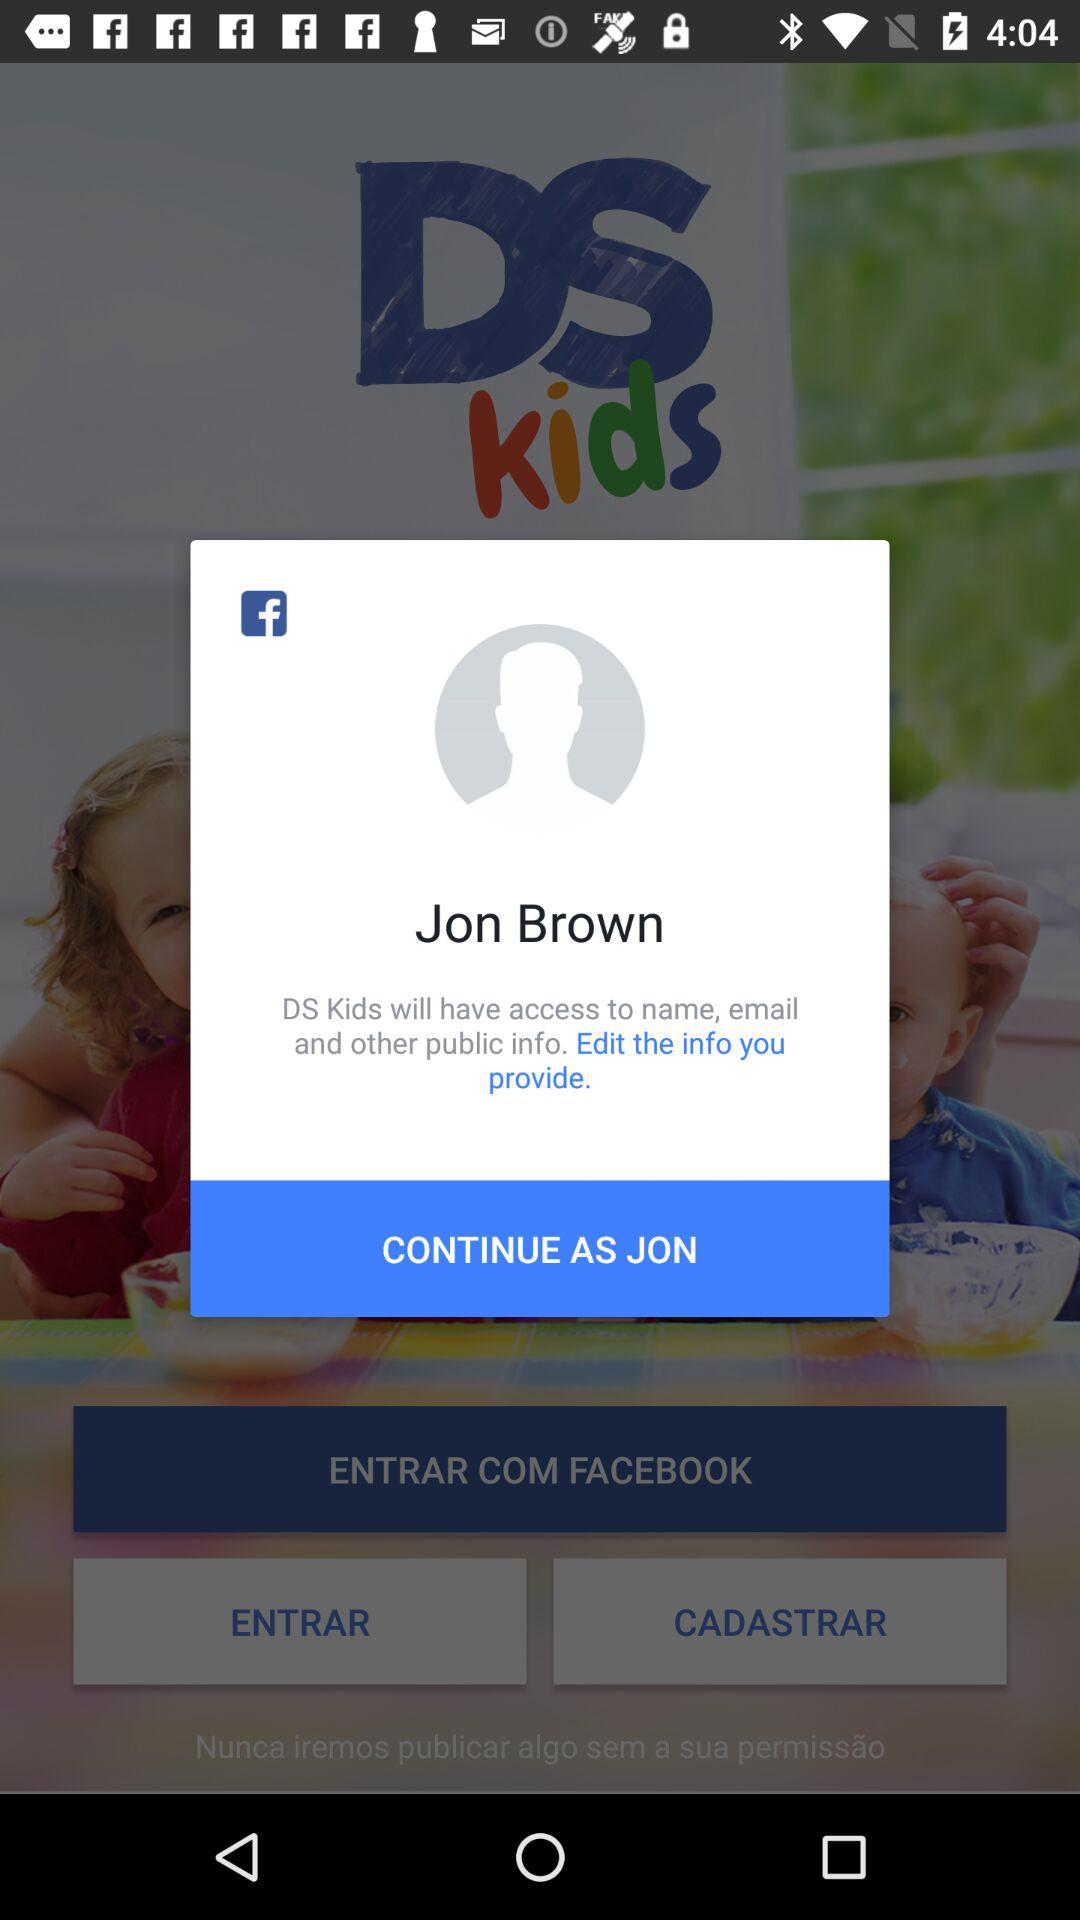What things does "DS Kids" want access to? "DS Kids" wants access to names, emails and other public info. 